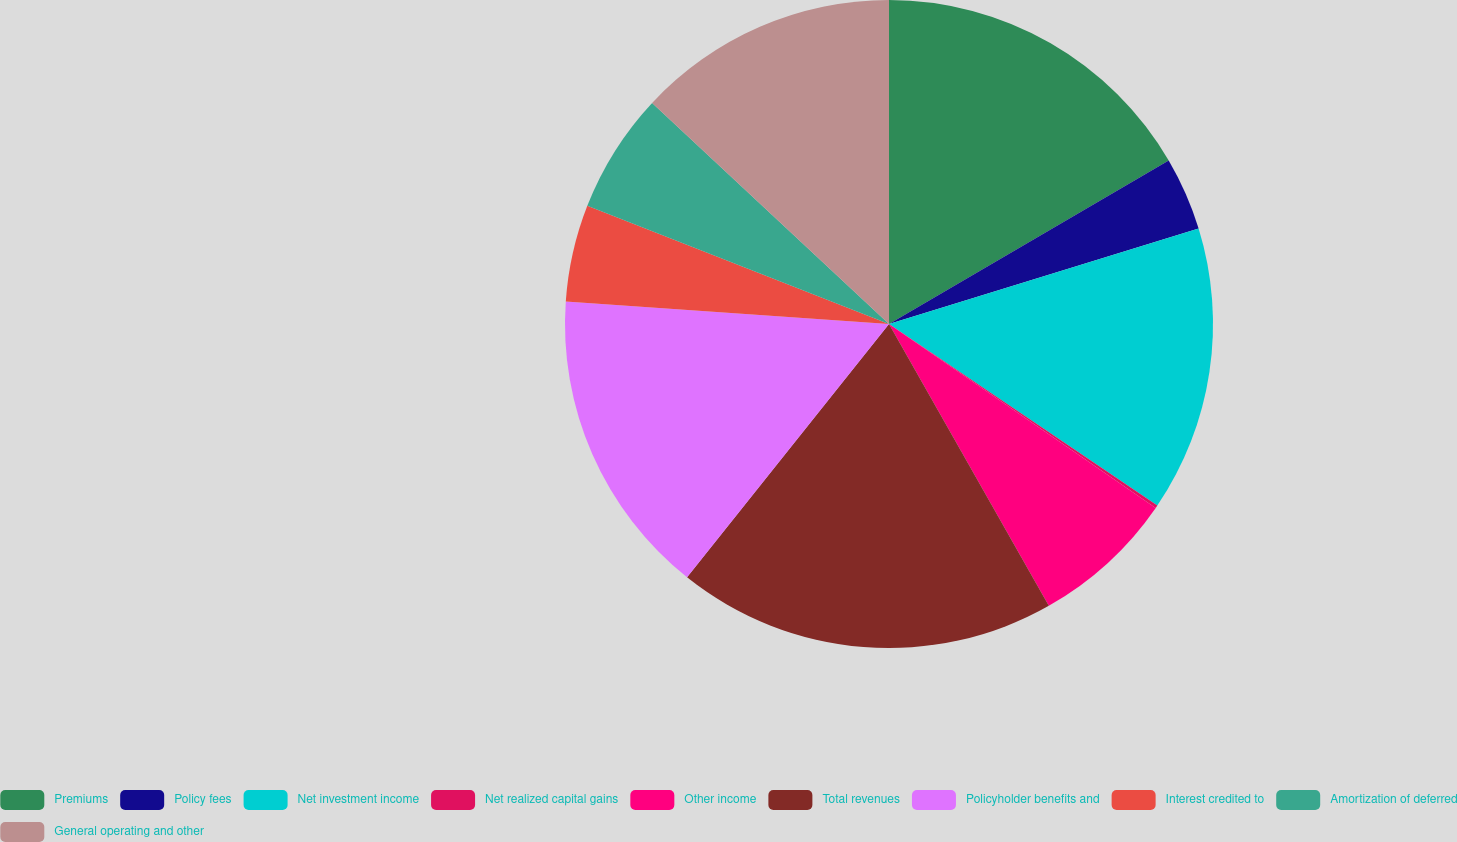Convert chart to OTSL. <chart><loc_0><loc_0><loc_500><loc_500><pie_chart><fcel>Premiums<fcel>Policy fees<fcel>Net investment income<fcel>Net realized capital gains<fcel>Other income<fcel>Total revenues<fcel>Policyholder benefits and<fcel>Interest credited to<fcel>Amortization of deferred<fcel>General operating and other<nl><fcel>16.58%<fcel>3.66%<fcel>14.23%<fcel>0.14%<fcel>7.18%<fcel>18.92%<fcel>15.4%<fcel>4.83%<fcel>6.01%<fcel>13.05%<nl></chart> 